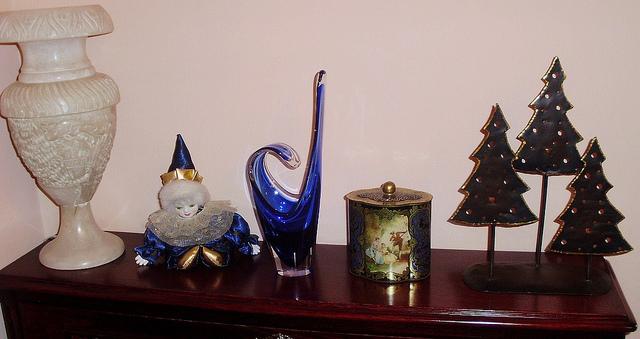What are the vases sitting on?
Keep it brief. Table. How many trees on the table?
Answer briefly. 3. How many horns are in the picture?
Give a very brief answer. 0. What color is the middle vase?
Keep it brief. Blue. What is the table made of?
Be succinct. Wood. What kind of trees are on the table?
Keep it brief. Christmas. Is this a wedding?
Keep it brief. No. 